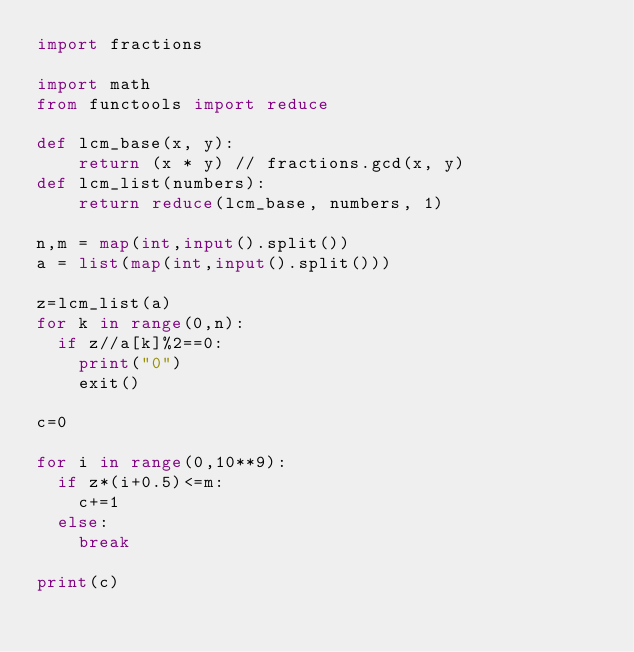Convert code to text. <code><loc_0><loc_0><loc_500><loc_500><_Python_>import fractions

import math
from functools import reduce

def lcm_base(x, y):
    return (x * y) // fractions.gcd(x, y)
def lcm_list(numbers):
    return reduce(lcm_base, numbers, 1)
  
n,m = map(int,input().split())
a = list(map(int,input().split()))

z=lcm_list(a)
for k in range(0,n):
  if z//a[k]%2==0:
    print("0")
    exit()

c=0

for i in range(0,10**9):
  if z*(i+0.5)<=m:
    c+=1
  else:
    break

print(c)

</code> 